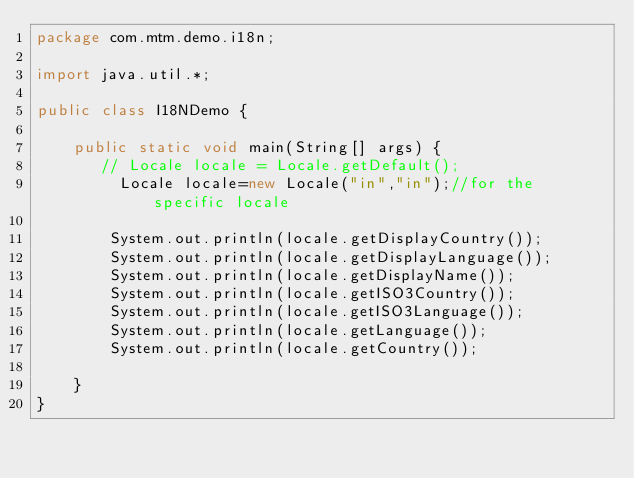Convert code to text. <code><loc_0><loc_0><loc_500><loc_500><_Java_>package com.mtm.demo.i18n;

import java.util.*;

public class I18NDemo {

    public static void main(String[] args) {
       // Locale locale = Locale.getDefault();
         Locale locale=new Locale("in","in");//for the specific locale

        System.out.println(locale.getDisplayCountry());
        System.out.println(locale.getDisplayLanguage());
        System.out.println(locale.getDisplayName());
        System.out.println(locale.getISO3Country());
        System.out.println(locale.getISO3Language());
        System.out.println(locale.getLanguage());
        System.out.println(locale.getCountry());

    }
}
</code> 